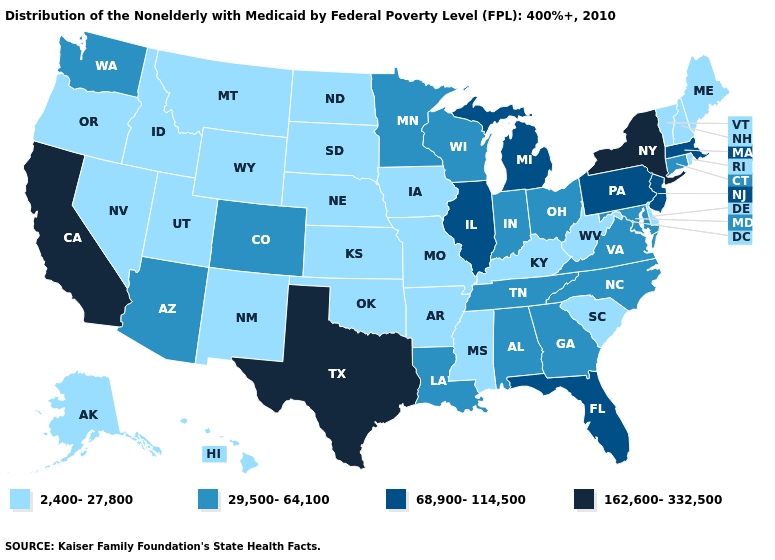Among the states that border Vermont , does Massachusetts have the highest value?
Quick response, please. No. What is the value of South Carolina?
Short answer required. 2,400-27,800. Which states hav the highest value in the West?
Quick response, please. California. What is the highest value in states that border Maryland?
Give a very brief answer. 68,900-114,500. Name the states that have a value in the range 162,600-332,500?
Answer briefly. California, New York, Texas. Among the states that border Indiana , which have the lowest value?
Answer briefly. Kentucky. Does Nevada have the same value as West Virginia?
Give a very brief answer. Yes. Name the states that have a value in the range 29,500-64,100?
Write a very short answer. Alabama, Arizona, Colorado, Connecticut, Georgia, Indiana, Louisiana, Maryland, Minnesota, North Carolina, Ohio, Tennessee, Virginia, Washington, Wisconsin. What is the value of New Jersey?
Short answer required. 68,900-114,500. Which states have the highest value in the USA?
Quick response, please. California, New York, Texas. What is the value of West Virginia?
Concise answer only. 2,400-27,800. What is the value of West Virginia?
Concise answer only. 2,400-27,800. How many symbols are there in the legend?
Give a very brief answer. 4. What is the value of Massachusetts?
Be succinct. 68,900-114,500. Name the states that have a value in the range 162,600-332,500?
Answer briefly. California, New York, Texas. 